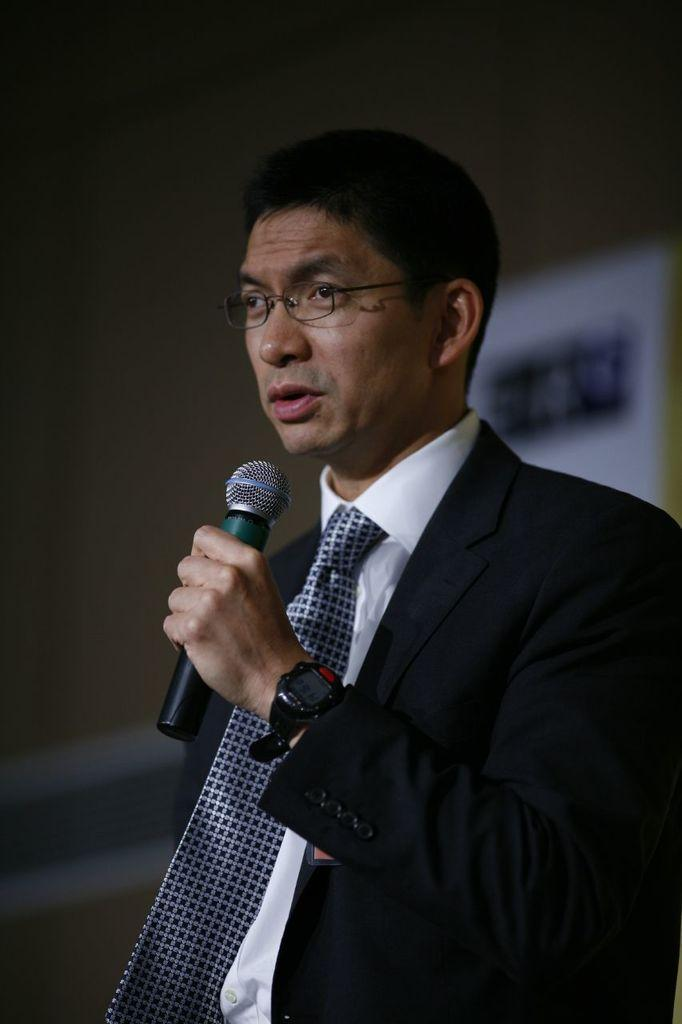What is the main subject of the image? The main subject of the image is a man. What is the man wearing on his upper body? The man is wearing a black jacket and a white shirt. Is the man wearing any accessories? Yes, the man is wearing a tie and a watch on his left hand. What is the man holding in his left hand? The man is holding a mic in his left hand. Can you describe the man's eyewear? The man is wearing spectacles. What type of cub can be seen playing in the bushes in the image? There is no cub or bushes present in the image; it features a man holding a mic and wearing a black jacket, white shirt, tie, and watch. 